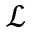Convert formula to latex. <formula><loc_0><loc_0><loc_500><loc_500>\mathcal { L }</formula> 